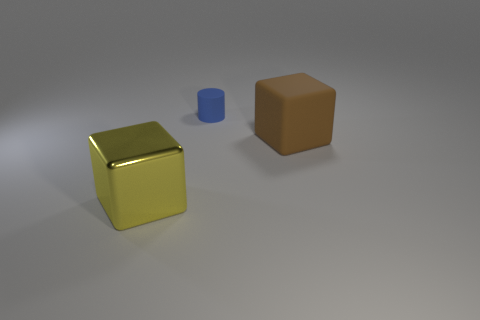Add 3 blue rubber cylinders. How many objects exist? 6 Subtract all yellow blocks. How many blocks are left? 1 Subtract all small yellow shiny cylinders. Subtract all yellow metallic things. How many objects are left? 2 Add 1 blue rubber cylinders. How many blue rubber cylinders are left? 2 Add 3 blue cylinders. How many blue cylinders exist? 4 Subtract 0 purple cylinders. How many objects are left? 3 Subtract all cylinders. How many objects are left? 2 Subtract all green cubes. Subtract all purple balls. How many cubes are left? 2 Subtract all green balls. How many brown blocks are left? 1 